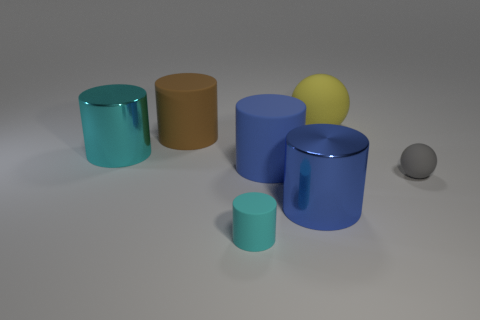The shiny object left of the cylinder on the right side of the blue matte cylinder is what color? The shiny cylindrical object located to the left of the larger cylinder at the far right of the image is cyan in color. Its reflective surface gives it an illuminating appearance contrasted against the more subdued hues in the scene. 